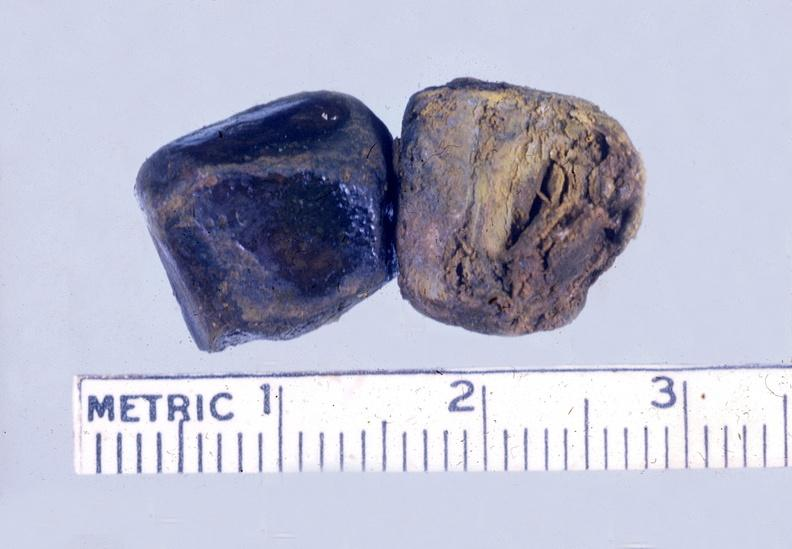s liver present?
Answer the question using a single word or phrase. Yes 